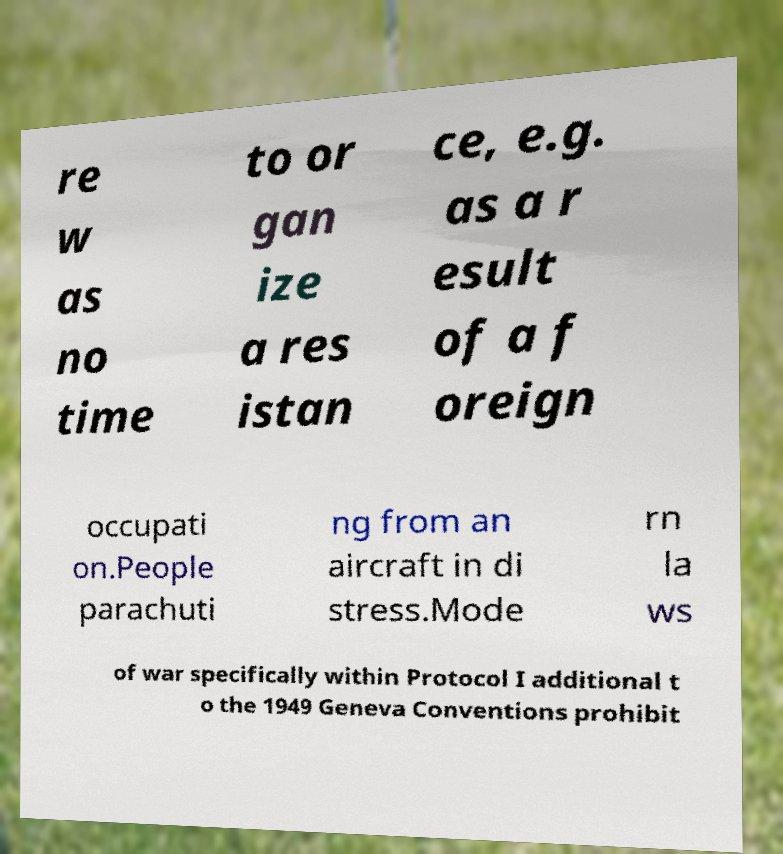What messages or text are displayed in this image? I need them in a readable, typed format. re w as no time to or gan ize a res istan ce, e.g. as a r esult of a f oreign occupati on.People parachuti ng from an aircraft in di stress.Mode rn la ws of war specifically within Protocol I additional t o the 1949 Geneva Conventions prohibit 